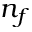Convert formula to latex. <formula><loc_0><loc_0><loc_500><loc_500>n _ { f }</formula> 